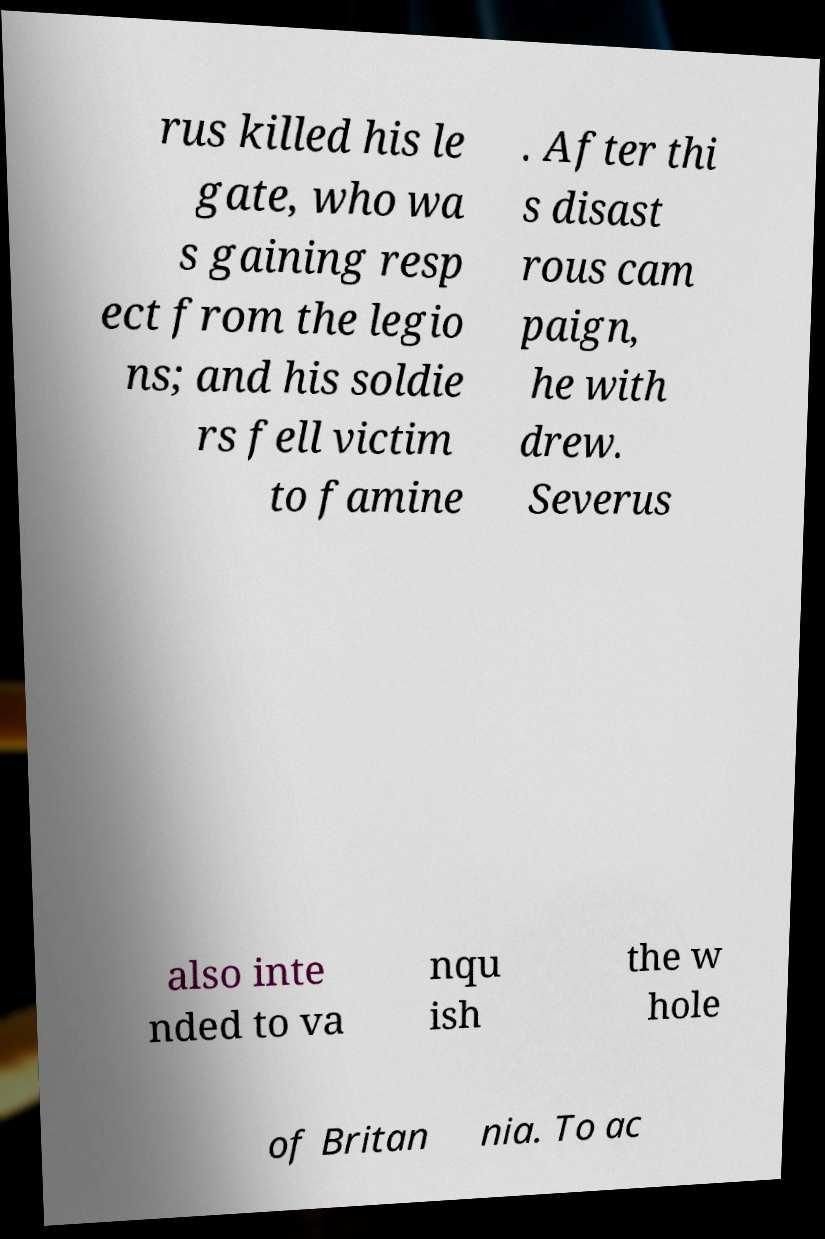Please identify and transcribe the text found in this image. rus killed his le gate, who wa s gaining resp ect from the legio ns; and his soldie rs fell victim to famine . After thi s disast rous cam paign, he with drew. Severus also inte nded to va nqu ish the w hole of Britan nia. To ac 